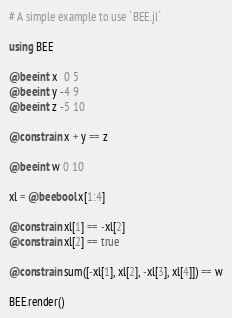<code> <loc_0><loc_0><loc_500><loc_500><_Julia_># A simple example to use `BEE.jl`

using BEE

@beeint x  0 5
@beeint y -4 9
@beeint z -5 10

@constrain x + y == z

@beeint w 0 10

xl = @beebool x[1:4]

@constrain xl[1] == -xl[2]
@constrain xl[2] == true

@constrain sum([-xl[1], xl[2], -xl[3], xl[4]]) == w

BEE.render()
</code> 